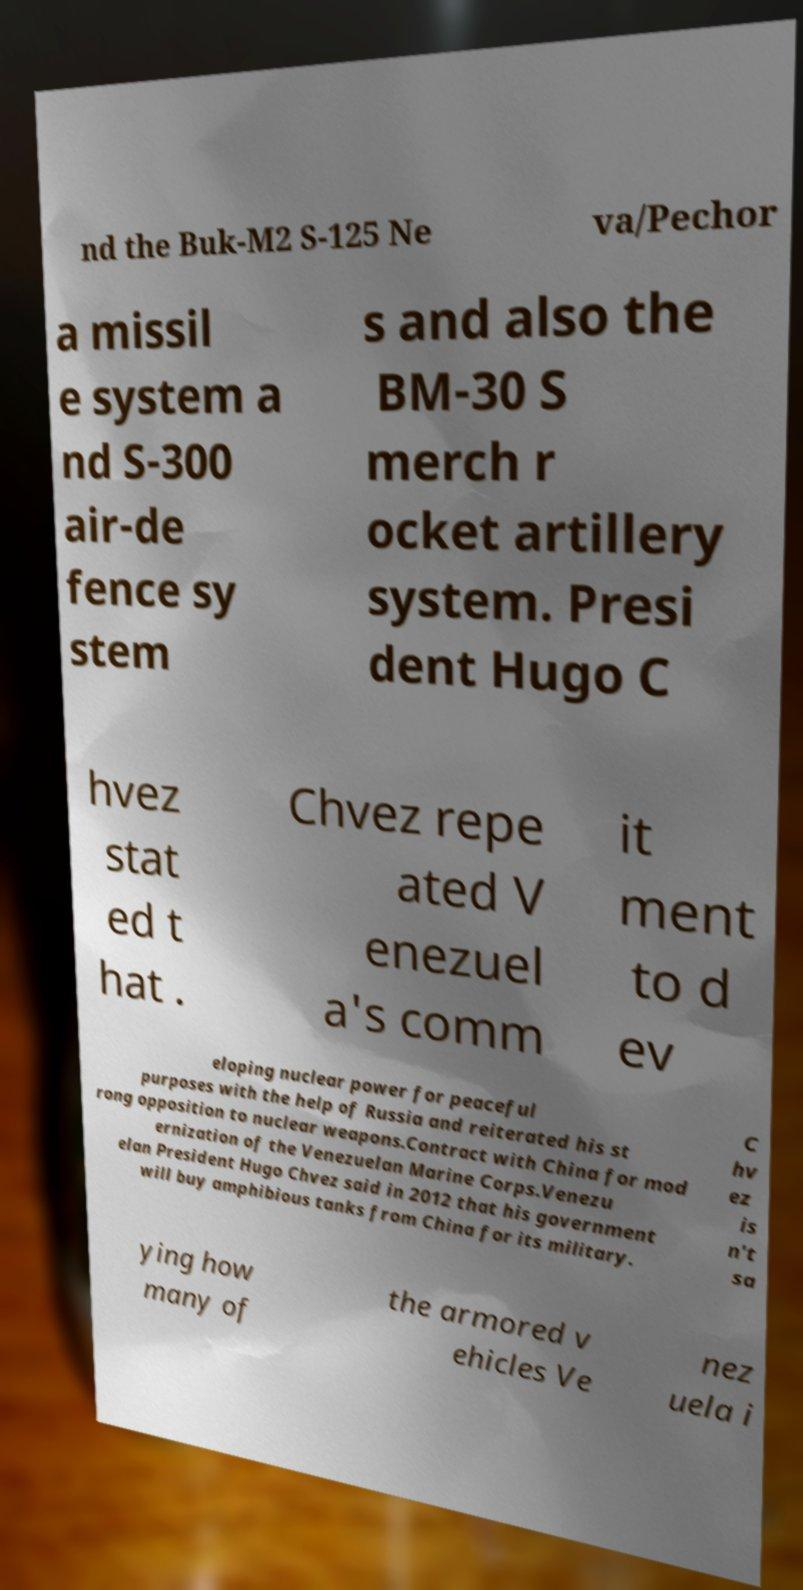Could you assist in decoding the text presented in this image and type it out clearly? nd the Buk-M2 S-125 Ne va/Pechor a missil e system a nd S-300 air-de fence sy stem s and also the BM-30 S merch r ocket artillery system. Presi dent Hugo C hvez stat ed t hat . Chvez repe ated V enezuel a's comm it ment to d ev eloping nuclear power for peaceful purposes with the help of Russia and reiterated his st rong opposition to nuclear weapons.Contract with China for mod ernization of the Venezuelan Marine Corps.Venezu elan President Hugo Chvez said in 2012 that his government will buy amphibious tanks from China for its military. C hv ez is n't sa ying how many of the armored v ehicles Ve nez uela i 